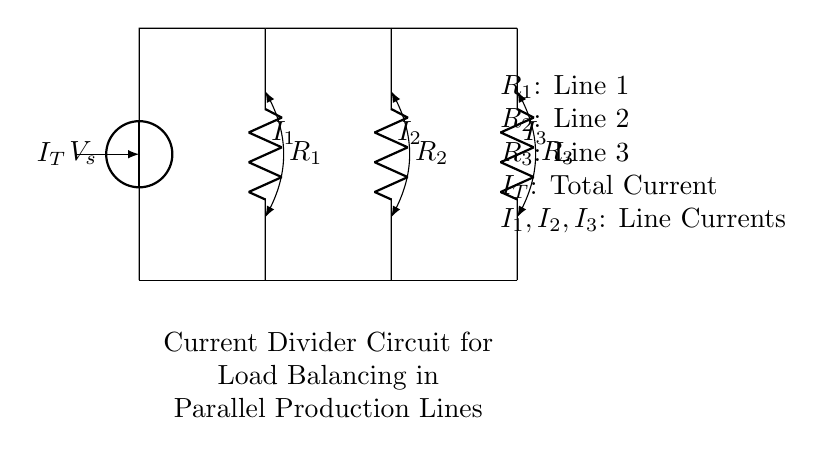What is the total current entering the circuit? The total current entering the circuit is labeled as I_T on the left side, indicating the sum of the currents flowing through each load.
Answer: I_T What is the resistance value of Line 2? In the circuit, Line 2 is represented by the resistor R_2. The diagram does not specify numerical values but denotes each resistor with a label.
Answer: R_2 What can be inferred about the current distribution in this circuit? Since the circuit is configured as a current divider, the total current I_T is divided among the parallel resistors R_1, R_2, and R_3. The current flowing through each resistor is denoted as I_1, I_2, and I_3, respectively.
Answer: It will divide based on resistance values If R_1 is doubled while keeping R_2 and R_3 constant, how will I_1 change? According to the current divider rule, if the resistance in one branch (R_1) is increased, the current I_1 through that branch will decrease as the total current remains the same. The reduction in current I_1 will be inversely proportional to the increase in R_1.
Answer: I_1 will decrease Which line will have the highest current under equal voltage conditions? In a current divider circuit, the line with the lowest resistance will carry the highest current. Thus, the line that corresponds to the smallest resistor provides the explanation for the highest current flow.
Answer: The line with the smallest resistance What does the bending arrows represent in the circuit? The bending arrows in the circuit indicate the direction of the current flow in each branch. They show how the total current is divided into I_1, I_2, and I_3 moving through their respective resistors.
Answer: The current direction 